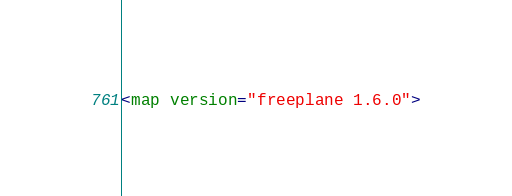<code> <loc_0><loc_0><loc_500><loc_500><_ObjectiveC_><map version="freeplane 1.6.0"></code> 